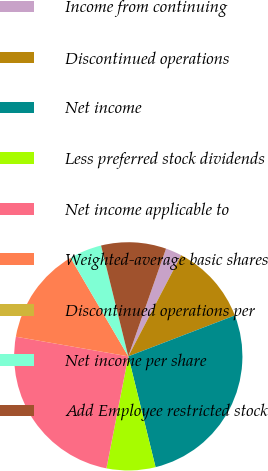<chart> <loc_0><loc_0><loc_500><loc_500><pie_chart><fcel>Income from continuing<fcel>Discontinued operations<fcel>Net income<fcel>Less preferred stock dividends<fcel>Net income applicable to<fcel>Weighted-average basic shares<fcel>Discontinued operations per<fcel>Net income per share<fcel>Add Employee restricted stock<nl><fcel>2.3%<fcel>11.5%<fcel>26.99%<fcel>6.9%<fcel>24.69%<fcel>13.81%<fcel>0.0%<fcel>4.6%<fcel>9.2%<nl></chart> 